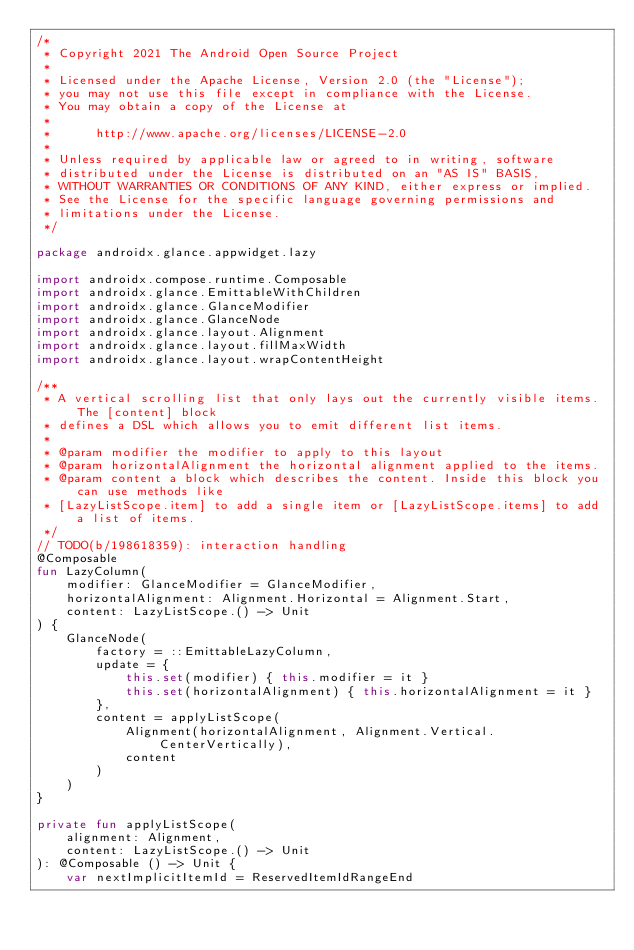<code> <loc_0><loc_0><loc_500><loc_500><_Kotlin_>/*
 * Copyright 2021 The Android Open Source Project
 *
 * Licensed under the Apache License, Version 2.0 (the "License");
 * you may not use this file except in compliance with the License.
 * You may obtain a copy of the License at
 *
 *      http://www.apache.org/licenses/LICENSE-2.0
 *
 * Unless required by applicable law or agreed to in writing, software
 * distributed under the License is distributed on an "AS IS" BASIS,
 * WITHOUT WARRANTIES OR CONDITIONS OF ANY KIND, either express or implied.
 * See the License for the specific language governing permissions and
 * limitations under the License.
 */

package androidx.glance.appwidget.lazy

import androidx.compose.runtime.Composable
import androidx.glance.EmittableWithChildren
import androidx.glance.GlanceModifier
import androidx.glance.GlanceNode
import androidx.glance.layout.Alignment
import androidx.glance.layout.fillMaxWidth
import androidx.glance.layout.wrapContentHeight

/**
 * A vertical scrolling list that only lays out the currently visible items. The [content] block
 * defines a DSL which allows you to emit different list items.
 *
 * @param modifier the modifier to apply to this layout
 * @param horizontalAlignment the horizontal alignment applied to the items.
 * @param content a block which describes the content. Inside this block you can use methods like
 * [LazyListScope.item] to add a single item or [LazyListScope.items] to add a list of items.
 */
// TODO(b/198618359): interaction handling
@Composable
fun LazyColumn(
    modifier: GlanceModifier = GlanceModifier,
    horizontalAlignment: Alignment.Horizontal = Alignment.Start,
    content: LazyListScope.() -> Unit
) {
    GlanceNode(
        factory = ::EmittableLazyColumn,
        update = {
            this.set(modifier) { this.modifier = it }
            this.set(horizontalAlignment) { this.horizontalAlignment = it }
        },
        content = applyListScope(
            Alignment(horizontalAlignment, Alignment.Vertical.CenterVertically),
            content
        )
    )
}

private fun applyListScope(
    alignment: Alignment,
    content: LazyListScope.() -> Unit
): @Composable () -> Unit {
    var nextImplicitItemId = ReservedItemIdRangeEnd</code> 